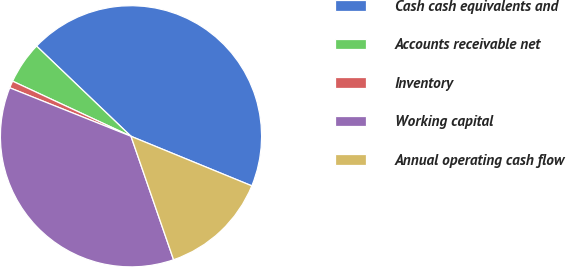<chart> <loc_0><loc_0><loc_500><loc_500><pie_chart><fcel>Cash cash equivalents and<fcel>Accounts receivable net<fcel>Inventory<fcel>Working capital<fcel>Annual operating cash flow<nl><fcel>44.06%<fcel>5.2%<fcel>0.88%<fcel>36.34%<fcel>13.52%<nl></chart> 